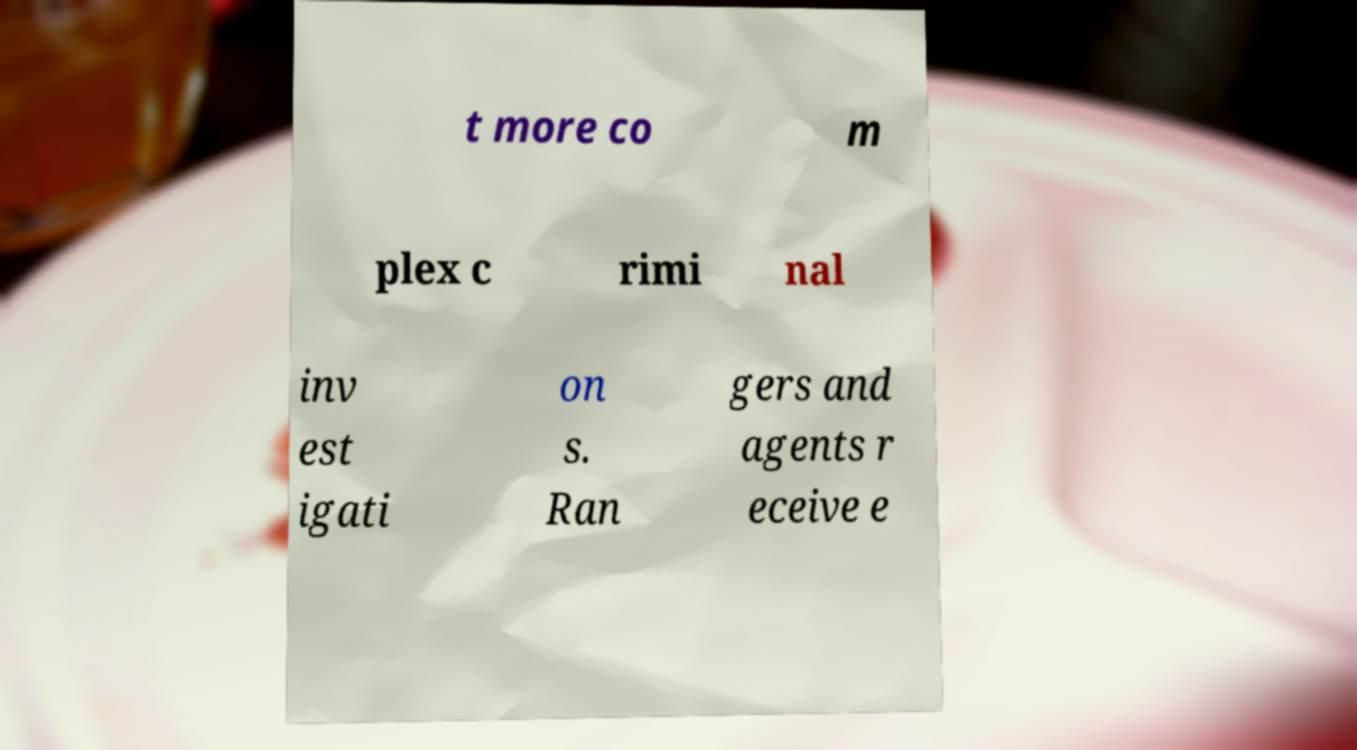Could you extract and type out the text from this image? t more co m plex c rimi nal inv est igati on s. Ran gers and agents r eceive e 